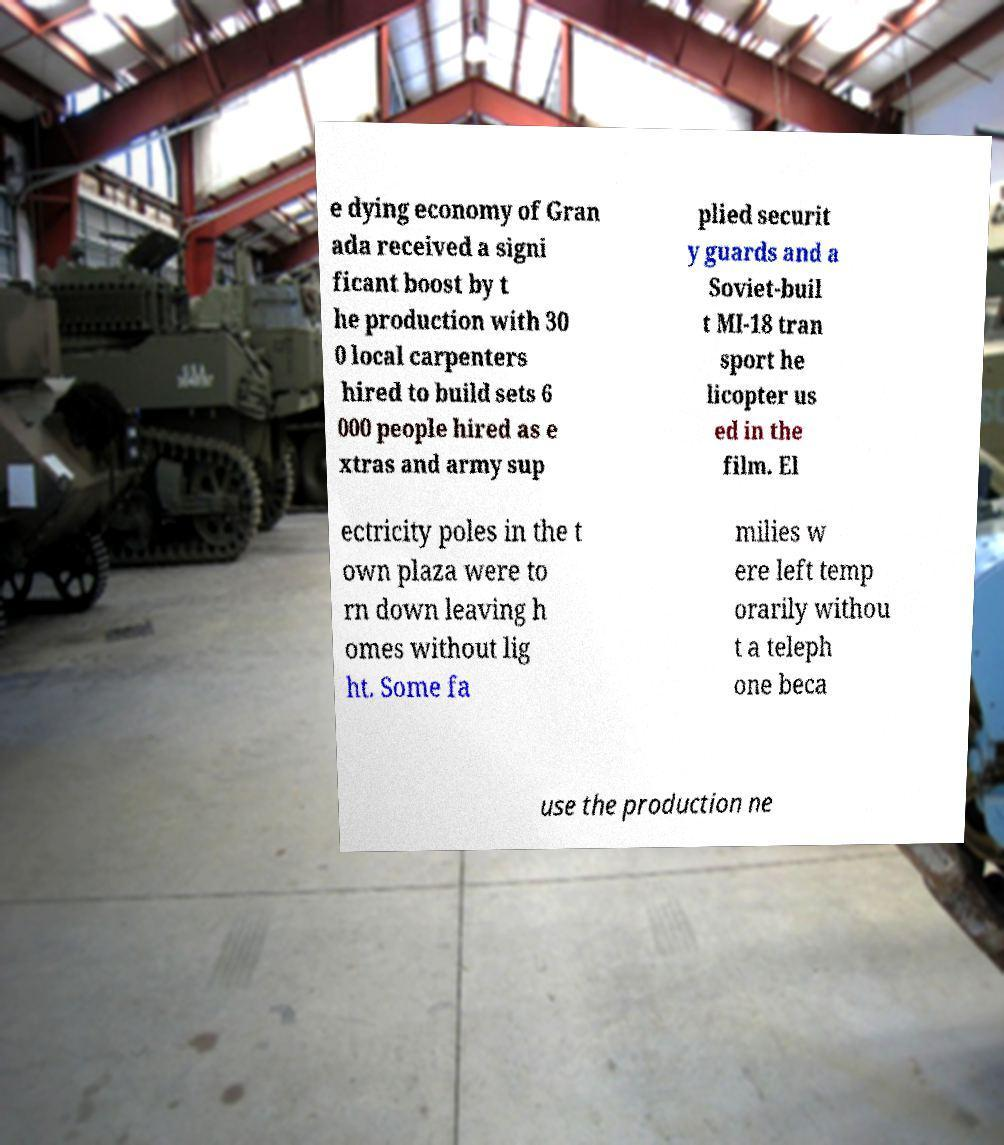For documentation purposes, I need the text within this image transcribed. Could you provide that? e dying economy of Gran ada received a signi ficant boost by t he production with 30 0 local carpenters hired to build sets 6 000 people hired as e xtras and army sup plied securit y guards and a Soviet-buil t MI-18 tran sport he licopter us ed in the film. El ectricity poles in the t own plaza were to rn down leaving h omes without lig ht. Some fa milies w ere left temp orarily withou t a teleph one beca use the production ne 